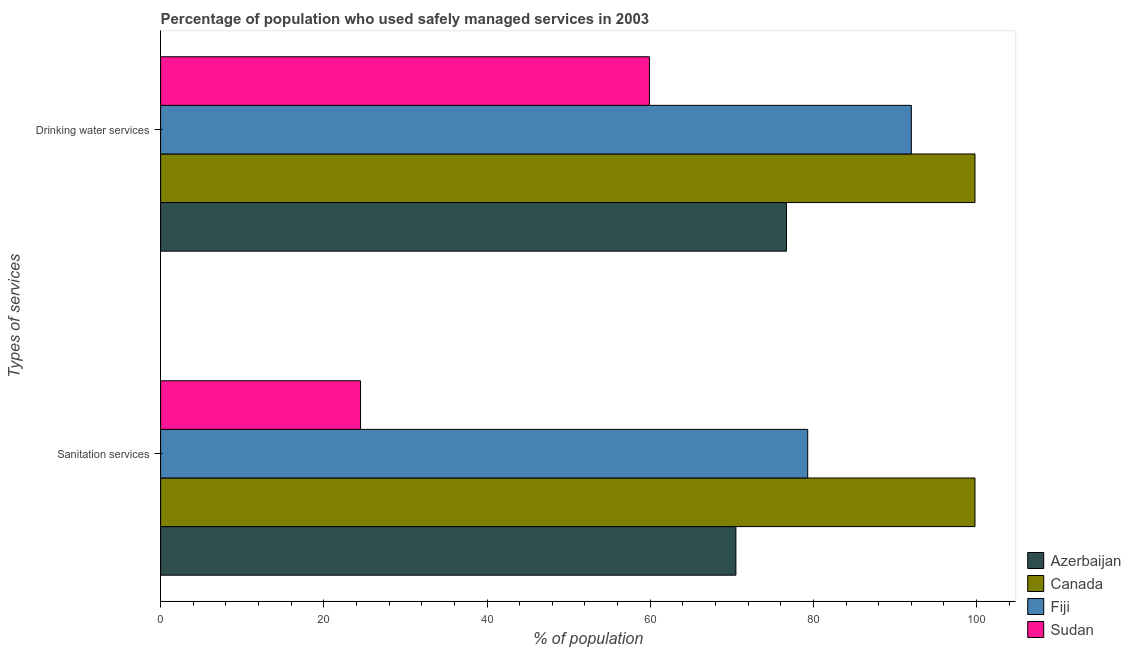How many different coloured bars are there?
Give a very brief answer. 4. Are the number of bars on each tick of the Y-axis equal?
Your answer should be compact. Yes. How many bars are there on the 2nd tick from the bottom?
Provide a short and direct response. 4. What is the label of the 2nd group of bars from the top?
Your answer should be compact. Sanitation services. What is the percentage of population who used drinking water services in Canada?
Your response must be concise. 99.8. Across all countries, what is the maximum percentage of population who used sanitation services?
Your answer should be compact. 99.8. Across all countries, what is the minimum percentage of population who used drinking water services?
Ensure brevity in your answer.  59.9. In which country was the percentage of population who used drinking water services minimum?
Give a very brief answer. Sudan. What is the total percentage of population who used drinking water services in the graph?
Offer a terse response. 328.4. What is the difference between the percentage of population who used sanitation services in Canada and that in Sudan?
Provide a succinct answer. 75.3. What is the difference between the percentage of population who used sanitation services in Fiji and the percentage of population who used drinking water services in Canada?
Provide a succinct answer. -20.5. What is the average percentage of population who used drinking water services per country?
Give a very brief answer. 82.1. What is the ratio of the percentage of population who used drinking water services in Sudan to that in Canada?
Provide a short and direct response. 0.6. Is the percentage of population who used drinking water services in Fiji less than that in Azerbaijan?
Offer a very short reply. No. What does the 4th bar from the top in Sanitation services represents?
Your response must be concise. Azerbaijan. How many bars are there?
Your answer should be very brief. 8. What is the difference between two consecutive major ticks on the X-axis?
Keep it short and to the point. 20. Where does the legend appear in the graph?
Give a very brief answer. Bottom right. How are the legend labels stacked?
Your answer should be very brief. Vertical. What is the title of the graph?
Your answer should be compact. Percentage of population who used safely managed services in 2003. What is the label or title of the X-axis?
Give a very brief answer. % of population. What is the label or title of the Y-axis?
Give a very brief answer. Types of services. What is the % of population in Azerbaijan in Sanitation services?
Provide a short and direct response. 70.5. What is the % of population in Canada in Sanitation services?
Your answer should be compact. 99.8. What is the % of population in Fiji in Sanitation services?
Offer a terse response. 79.3. What is the % of population of Azerbaijan in Drinking water services?
Ensure brevity in your answer.  76.7. What is the % of population in Canada in Drinking water services?
Your response must be concise. 99.8. What is the % of population of Fiji in Drinking water services?
Keep it short and to the point. 92. What is the % of population of Sudan in Drinking water services?
Your answer should be compact. 59.9. Across all Types of services, what is the maximum % of population in Azerbaijan?
Make the answer very short. 76.7. Across all Types of services, what is the maximum % of population in Canada?
Provide a succinct answer. 99.8. Across all Types of services, what is the maximum % of population of Fiji?
Make the answer very short. 92. Across all Types of services, what is the maximum % of population in Sudan?
Offer a terse response. 59.9. Across all Types of services, what is the minimum % of population in Azerbaijan?
Your response must be concise. 70.5. Across all Types of services, what is the minimum % of population of Canada?
Provide a succinct answer. 99.8. Across all Types of services, what is the minimum % of population in Fiji?
Provide a short and direct response. 79.3. What is the total % of population in Azerbaijan in the graph?
Give a very brief answer. 147.2. What is the total % of population of Canada in the graph?
Provide a short and direct response. 199.6. What is the total % of population of Fiji in the graph?
Your answer should be compact. 171.3. What is the total % of population in Sudan in the graph?
Offer a very short reply. 84.4. What is the difference between the % of population of Fiji in Sanitation services and that in Drinking water services?
Ensure brevity in your answer.  -12.7. What is the difference between the % of population in Sudan in Sanitation services and that in Drinking water services?
Your answer should be compact. -35.4. What is the difference between the % of population of Azerbaijan in Sanitation services and the % of population of Canada in Drinking water services?
Offer a very short reply. -29.3. What is the difference between the % of population of Azerbaijan in Sanitation services and the % of population of Fiji in Drinking water services?
Give a very brief answer. -21.5. What is the difference between the % of population of Canada in Sanitation services and the % of population of Fiji in Drinking water services?
Give a very brief answer. 7.8. What is the difference between the % of population in Canada in Sanitation services and the % of population in Sudan in Drinking water services?
Ensure brevity in your answer.  39.9. What is the average % of population of Azerbaijan per Types of services?
Offer a very short reply. 73.6. What is the average % of population of Canada per Types of services?
Keep it short and to the point. 99.8. What is the average % of population in Fiji per Types of services?
Your answer should be compact. 85.65. What is the average % of population in Sudan per Types of services?
Provide a succinct answer. 42.2. What is the difference between the % of population of Azerbaijan and % of population of Canada in Sanitation services?
Provide a succinct answer. -29.3. What is the difference between the % of population in Azerbaijan and % of population in Fiji in Sanitation services?
Offer a very short reply. -8.8. What is the difference between the % of population in Azerbaijan and % of population in Sudan in Sanitation services?
Keep it short and to the point. 46. What is the difference between the % of population in Canada and % of population in Sudan in Sanitation services?
Give a very brief answer. 75.3. What is the difference between the % of population of Fiji and % of population of Sudan in Sanitation services?
Keep it short and to the point. 54.8. What is the difference between the % of population of Azerbaijan and % of population of Canada in Drinking water services?
Your answer should be very brief. -23.1. What is the difference between the % of population in Azerbaijan and % of population in Fiji in Drinking water services?
Give a very brief answer. -15.3. What is the difference between the % of population in Azerbaijan and % of population in Sudan in Drinking water services?
Provide a short and direct response. 16.8. What is the difference between the % of population in Canada and % of population in Fiji in Drinking water services?
Provide a succinct answer. 7.8. What is the difference between the % of population in Canada and % of population in Sudan in Drinking water services?
Make the answer very short. 39.9. What is the difference between the % of population of Fiji and % of population of Sudan in Drinking water services?
Your answer should be compact. 32.1. What is the ratio of the % of population of Azerbaijan in Sanitation services to that in Drinking water services?
Your response must be concise. 0.92. What is the ratio of the % of population of Canada in Sanitation services to that in Drinking water services?
Provide a short and direct response. 1. What is the ratio of the % of population in Fiji in Sanitation services to that in Drinking water services?
Ensure brevity in your answer.  0.86. What is the ratio of the % of population in Sudan in Sanitation services to that in Drinking water services?
Offer a very short reply. 0.41. What is the difference between the highest and the second highest % of population in Sudan?
Offer a terse response. 35.4. What is the difference between the highest and the lowest % of population in Azerbaijan?
Your answer should be compact. 6.2. What is the difference between the highest and the lowest % of population in Fiji?
Provide a short and direct response. 12.7. What is the difference between the highest and the lowest % of population in Sudan?
Offer a terse response. 35.4. 